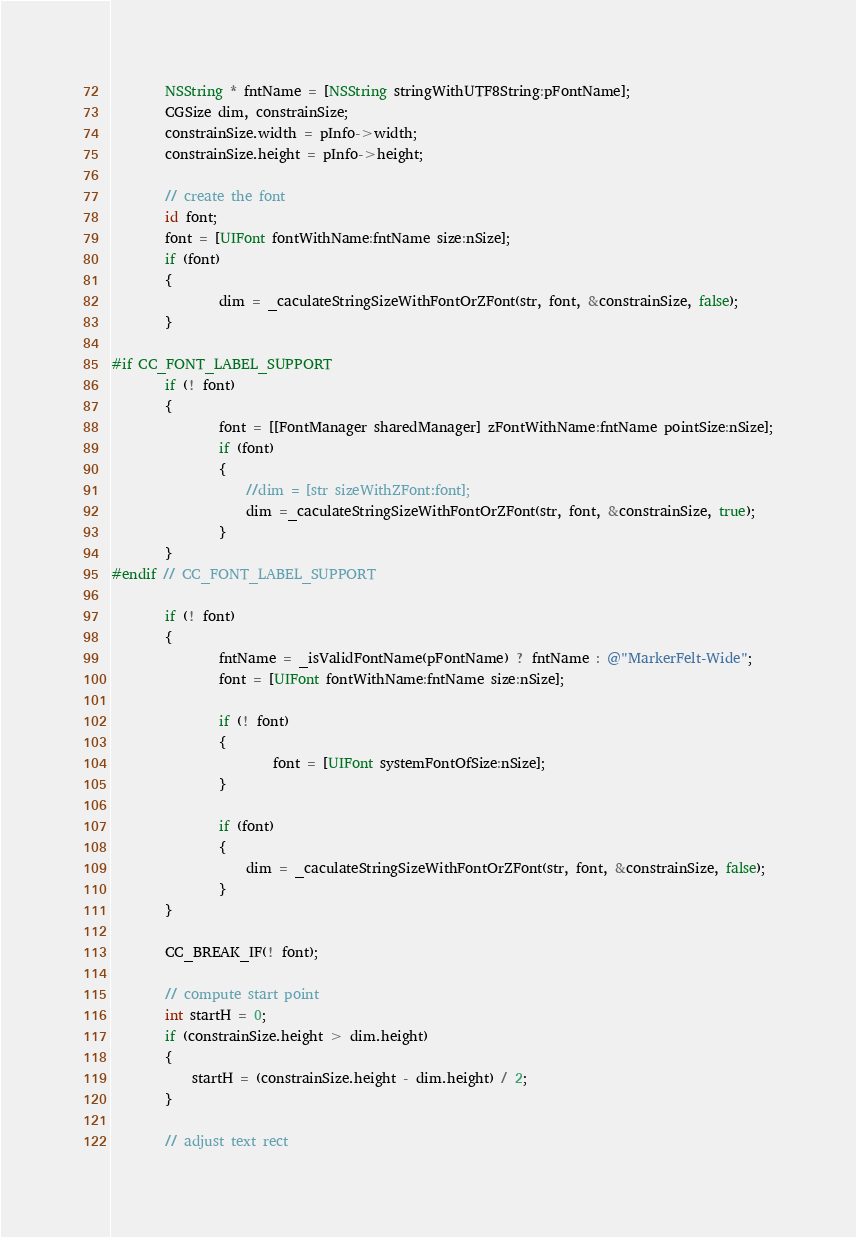Convert code to text. <code><loc_0><loc_0><loc_500><loc_500><_ObjectiveC_>        NSString * fntName = [NSString stringWithUTF8String:pFontName];
        CGSize dim, constrainSize;
        constrainSize.width = pInfo->width;
        constrainSize.height = pInfo->height;
        
        // create the font   
        id font;
        font = [UIFont fontWithName:fntName size:nSize];  
        if (font)
        {
                dim = _caculateStringSizeWithFontOrZFont(str, font, &constrainSize, false);
        }      
        
#if CC_FONT_LABEL_SUPPORT
	    if (! font)
	    {
		        font = [[FontManager sharedManager] zFontWithName:fntName pointSize:nSize];
		        if (font)
                {
                    //dim = [str sizeWithZFont:font];
                    dim =_caculateStringSizeWithFontOrZFont(str, font, &constrainSize, true);
                }  
	    }
#endif // CC_FONT_LABEL_SUPPORT

        if (! font)
        {
                fntName = _isValidFontName(pFontName) ? fntName : @"MarkerFelt-Wide";
                font = [UIFont fontWithName:fntName size:nSize];
                
                if (! font) 
                {
                        font = [UIFont systemFontOfSize:nSize];
                }
                
                if (font)
                {
                    dim = _caculateStringSizeWithFontOrZFont(str, font, &constrainSize, false);
                }  
        }

        CC_BREAK_IF(! font);
        
        // compute start point
        int startH = 0;
        if (constrainSize.height > dim.height)
        {
            startH = (constrainSize.height - dim.height) / 2;
        }
        
        // adjust text rect</code> 